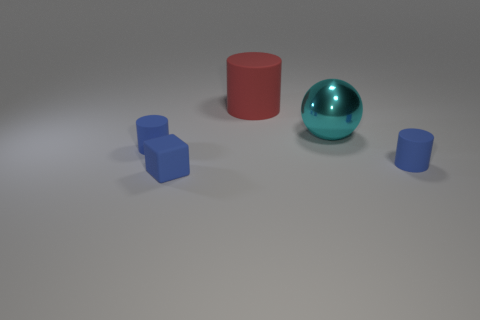What number of metal things are large objects or cyan spheres?
Your response must be concise. 1. Is there any other thing that is the same size as the metallic ball?
Your answer should be compact. Yes. There is a thing that is in front of the tiny cylinder that is to the right of the cyan metal sphere; what is its shape?
Provide a short and direct response. Cube. Are the tiny blue object on the left side of the small blue rubber block and the small cylinder right of the big red rubber thing made of the same material?
Your answer should be very brief. Yes. How many big cyan spheres are right of the tiny matte cylinder on the left side of the blue block?
Offer a very short reply. 1. There is a small rubber thing right of the large matte cylinder; is it the same shape as the big metallic object that is in front of the red rubber cylinder?
Offer a very short reply. No. How big is the thing that is in front of the metallic object and on the right side of the big red cylinder?
Keep it short and to the point. Small. What is the color of the matte cylinder that is on the right side of the cylinder behind the big cyan ball?
Give a very brief answer. Blue. What is the shape of the large red rubber thing?
Ensure brevity in your answer.  Cylinder. The large cylinder that is the same material as the tiny blue cube is what color?
Offer a terse response. Red. 